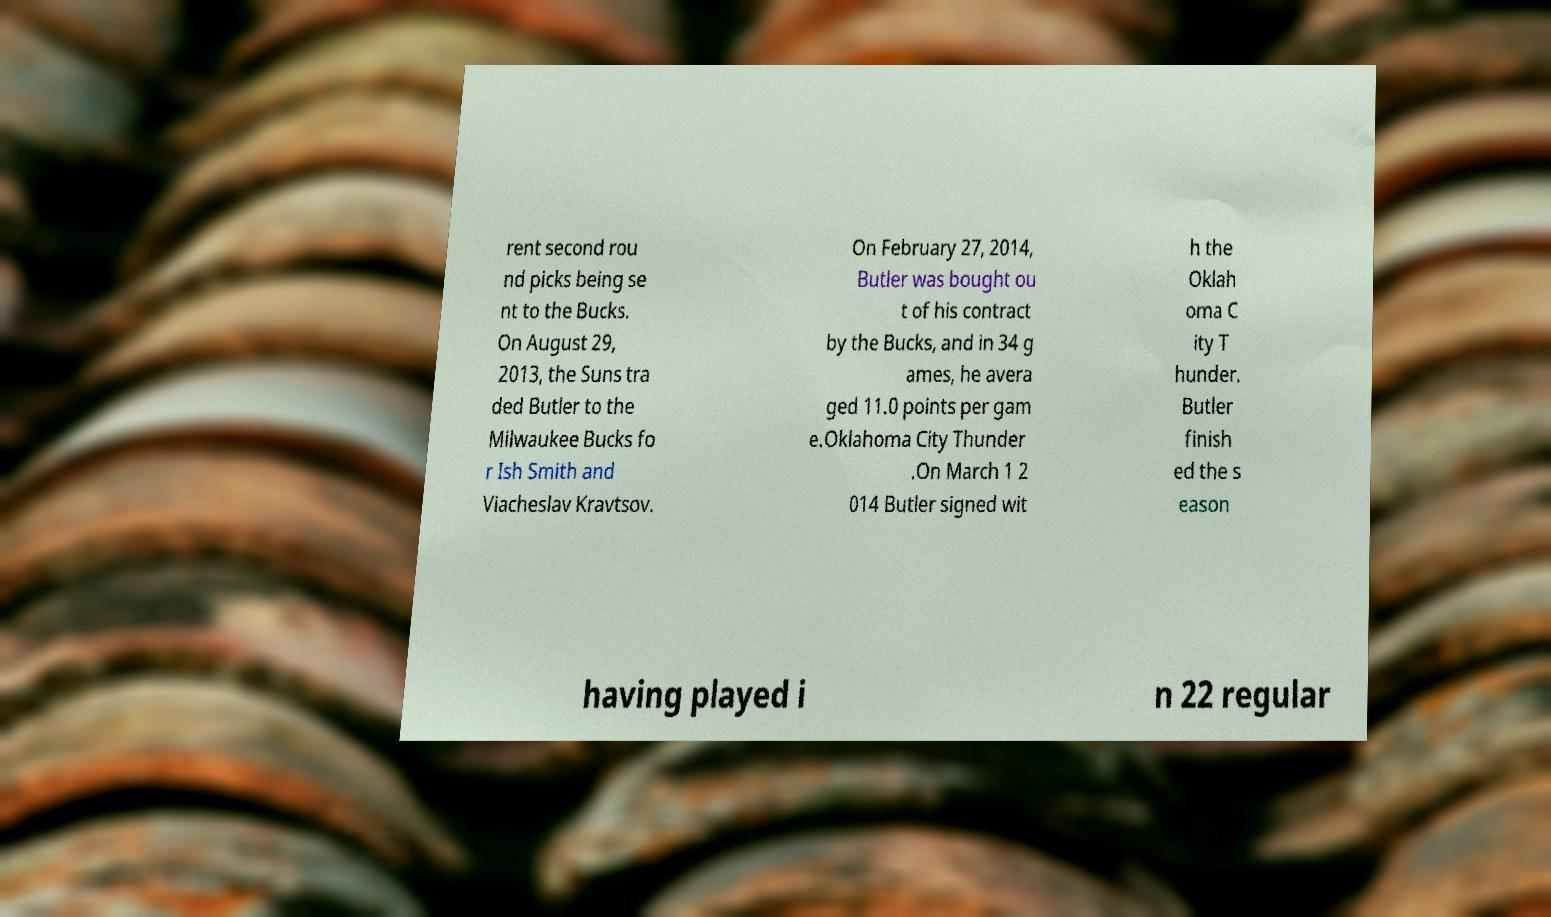Can you accurately transcribe the text from the provided image for me? rent second rou nd picks being se nt to the Bucks. On August 29, 2013, the Suns tra ded Butler to the Milwaukee Bucks fo r Ish Smith and Viacheslav Kravtsov. On February 27, 2014, Butler was bought ou t of his contract by the Bucks, and in 34 g ames, he avera ged 11.0 points per gam e.Oklahoma City Thunder .On March 1 2 014 Butler signed wit h the Oklah oma C ity T hunder. Butler finish ed the s eason having played i n 22 regular 